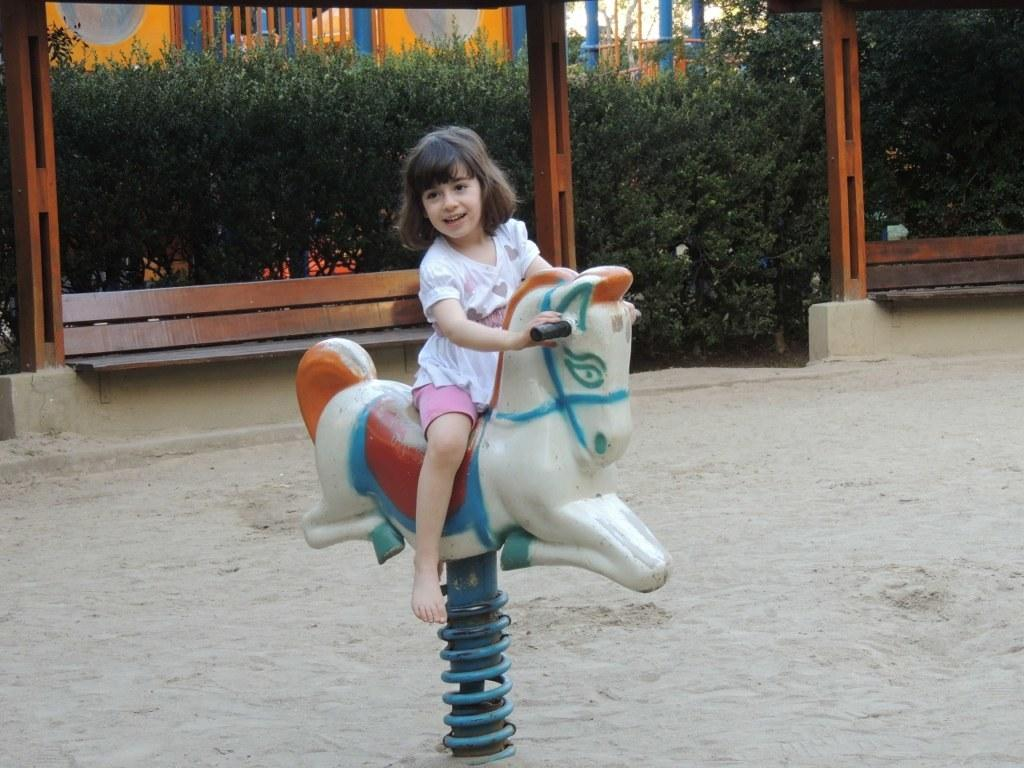Who is the main subject in the image? There is a girl in the image. What is the girl doing in the image? The girl is riding a toy horse. Where is the girl located in the image? The setting is a playground. What can be seen in the background of the image? There are plants and poles in the background of the image. What type of crime is being committed in the image? There is no crime being committed in the image; it depicts a girl riding a toy horse in a playground setting. 